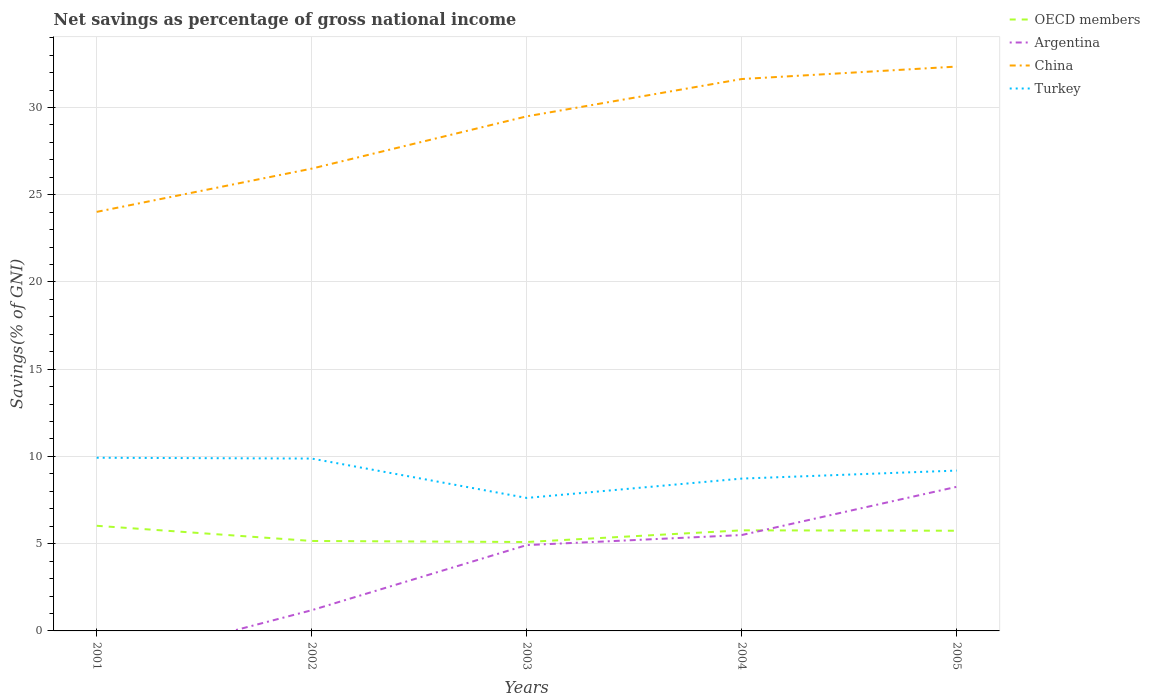How many different coloured lines are there?
Your response must be concise. 4. Does the line corresponding to China intersect with the line corresponding to Argentina?
Make the answer very short. No. Across all years, what is the maximum total savings in OECD members?
Provide a short and direct response. 5.1. What is the total total savings in OECD members in the graph?
Provide a succinct answer. -0.67. What is the difference between the highest and the second highest total savings in Argentina?
Ensure brevity in your answer.  8.26. What is the difference between the highest and the lowest total savings in China?
Offer a very short reply. 3. Does the graph contain grids?
Your response must be concise. Yes. Where does the legend appear in the graph?
Offer a terse response. Top right. How are the legend labels stacked?
Offer a terse response. Vertical. What is the title of the graph?
Provide a succinct answer. Net savings as percentage of gross national income. What is the label or title of the X-axis?
Your answer should be very brief. Years. What is the label or title of the Y-axis?
Your response must be concise. Savings(% of GNI). What is the Savings(% of GNI) of OECD members in 2001?
Provide a succinct answer. 6.03. What is the Savings(% of GNI) in Argentina in 2001?
Make the answer very short. 0. What is the Savings(% of GNI) in China in 2001?
Provide a short and direct response. 24.02. What is the Savings(% of GNI) in Turkey in 2001?
Make the answer very short. 9.93. What is the Savings(% of GNI) of OECD members in 2002?
Provide a short and direct response. 5.16. What is the Savings(% of GNI) of Argentina in 2002?
Your answer should be very brief. 1.19. What is the Savings(% of GNI) in China in 2002?
Your response must be concise. 26.49. What is the Savings(% of GNI) in Turkey in 2002?
Your answer should be compact. 9.88. What is the Savings(% of GNI) in OECD members in 2003?
Your response must be concise. 5.1. What is the Savings(% of GNI) of Argentina in 2003?
Give a very brief answer. 4.92. What is the Savings(% of GNI) of China in 2003?
Give a very brief answer. 29.49. What is the Savings(% of GNI) in Turkey in 2003?
Your answer should be compact. 7.62. What is the Savings(% of GNI) of OECD members in 2004?
Offer a very short reply. 5.76. What is the Savings(% of GNI) in Argentina in 2004?
Offer a terse response. 5.49. What is the Savings(% of GNI) of China in 2004?
Offer a terse response. 31.63. What is the Savings(% of GNI) of Turkey in 2004?
Ensure brevity in your answer.  8.73. What is the Savings(% of GNI) of OECD members in 2005?
Give a very brief answer. 5.74. What is the Savings(% of GNI) in Argentina in 2005?
Offer a terse response. 8.26. What is the Savings(% of GNI) of China in 2005?
Your answer should be compact. 32.34. What is the Savings(% of GNI) in Turkey in 2005?
Your response must be concise. 9.19. Across all years, what is the maximum Savings(% of GNI) in OECD members?
Ensure brevity in your answer.  6.03. Across all years, what is the maximum Savings(% of GNI) of Argentina?
Keep it short and to the point. 8.26. Across all years, what is the maximum Savings(% of GNI) of China?
Keep it short and to the point. 32.34. Across all years, what is the maximum Savings(% of GNI) in Turkey?
Your answer should be compact. 9.93. Across all years, what is the minimum Savings(% of GNI) in OECD members?
Give a very brief answer. 5.1. Across all years, what is the minimum Savings(% of GNI) of China?
Offer a terse response. 24.02. Across all years, what is the minimum Savings(% of GNI) of Turkey?
Keep it short and to the point. 7.62. What is the total Savings(% of GNI) of OECD members in the graph?
Provide a short and direct response. 27.78. What is the total Savings(% of GNI) of Argentina in the graph?
Provide a short and direct response. 19.86. What is the total Savings(% of GNI) of China in the graph?
Offer a very short reply. 143.98. What is the total Savings(% of GNI) of Turkey in the graph?
Your answer should be compact. 45.35. What is the difference between the Savings(% of GNI) of OECD members in 2001 and that in 2002?
Provide a short and direct response. 0.87. What is the difference between the Savings(% of GNI) in China in 2001 and that in 2002?
Your answer should be very brief. -2.48. What is the difference between the Savings(% of GNI) in Turkey in 2001 and that in 2002?
Give a very brief answer. 0.05. What is the difference between the Savings(% of GNI) in OECD members in 2001 and that in 2003?
Ensure brevity in your answer.  0.93. What is the difference between the Savings(% of GNI) in China in 2001 and that in 2003?
Provide a succinct answer. -5.47. What is the difference between the Savings(% of GNI) of Turkey in 2001 and that in 2003?
Offer a terse response. 2.3. What is the difference between the Savings(% of GNI) of OECD members in 2001 and that in 2004?
Provide a short and direct response. 0.26. What is the difference between the Savings(% of GNI) in China in 2001 and that in 2004?
Ensure brevity in your answer.  -7.61. What is the difference between the Savings(% of GNI) of Turkey in 2001 and that in 2004?
Your answer should be compact. 1.2. What is the difference between the Savings(% of GNI) of OECD members in 2001 and that in 2005?
Your answer should be compact. 0.28. What is the difference between the Savings(% of GNI) of China in 2001 and that in 2005?
Ensure brevity in your answer.  -8.33. What is the difference between the Savings(% of GNI) of Turkey in 2001 and that in 2005?
Offer a very short reply. 0.74. What is the difference between the Savings(% of GNI) in OECD members in 2002 and that in 2003?
Offer a terse response. 0.06. What is the difference between the Savings(% of GNI) of Argentina in 2002 and that in 2003?
Provide a succinct answer. -3.73. What is the difference between the Savings(% of GNI) in China in 2002 and that in 2003?
Give a very brief answer. -3. What is the difference between the Savings(% of GNI) of Turkey in 2002 and that in 2003?
Offer a very short reply. 2.26. What is the difference between the Savings(% of GNI) in OECD members in 2002 and that in 2004?
Your response must be concise. -0.61. What is the difference between the Savings(% of GNI) in Argentina in 2002 and that in 2004?
Provide a succinct answer. -4.31. What is the difference between the Savings(% of GNI) of China in 2002 and that in 2004?
Provide a succinct answer. -5.13. What is the difference between the Savings(% of GNI) in Turkey in 2002 and that in 2004?
Offer a very short reply. 1.15. What is the difference between the Savings(% of GNI) of OECD members in 2002 and that in 2005?
Give a very brief answer. -0.59. What is the difference between the Savings(% of GNI) in Argentina in 2002 and that in 2005?
Offer a terse response. -7.07. What is the difference between the Savings(% of GNI) in China in 2002 and that in 2005?
Ensure brevity in your answer.  -5.85. What is the difference between the Savings(% of GNI) in Turkey in 2002 and that in 2005?
Your answer should be compact. 0.69. What is the difference between the Savings(% of GNI) in OECD members in 2003 and that in 2004?
Your answer should be compact. -0.67. What is the difference between the Savings(% of GNI) of Argentina in 2003 and that in 2004?
Offer a very short reply. -0.58. What is the difference between the Savings(% of GNI) of China in 2003 and that in 2004?
Ensure brevity in your answer.  -2.14. What is the difference between the Savings(% of GNI) in Turkey in 2003 and that in 2004?
Provide a short and direct response. -1.11. What is the difference between the Savings(% of GNI) of OECD members in 2003 and that in 2005?
Your response must be concise. -0.65. What is the difference between the Savings(% of GNI) in Argentina in 2003 and that in 2005?
Give a very brief answer. -3.34. What is the difference between the Savings(% of GNI) of China in 2003 and that in 2005?
Make the answer very short. -2.85. What is the difference between the Savings(% of GNI) of Turkey in 2003 and that in 2005?
Offer a terse response. -1.57. What is the difference between the Savings(% of GNI) of OECD members in 2004 and that in 2005?
Offer a terse response. 0.02. What is the difference between the Savings(% of GNI) of Argentina in 2004 and that in 2005?
Keep it short and to the point. -2.76. What is the difference between the Savings(% of GNI) of China in 2004 and that in 2005?
Offer a very short reply. -0.71. What is the difference between the Savings(% of GNI) of Turkey in 2004 and that in 2005?
Your response must be concise. -0.46. What is the difference between the Savings(% of GNI) in OECD members in 2001 and the Savings(% of GNI) in Argentina in 2002?
Give a very brief answer. 4.84. What is the difference between the Savings(% of GNI) of OECD members in 2001 and the Savings(% of GNI) of China in 2002?
Give a very brief answer. -20.47. What is the difference between the Savings(% of GNI) of OECD members in 2001 and the Savings(% of GNI) of Turkey in 2002?
Provide a short and direct response. -3.85. What is the difference between the Savings(% of GNI) of China in 2001 and the Savings(% of GNI) of Turkey in 2002?
Make the answer very short. 14.14. What is the difference between the Savings(% of GNI) of OECD members in 2001 and the Savings(% of GNI) of Argentina in 2003?
Offer a terse response. 1.11. What is the difference between the Savings(% of GNI) in OECD members in 2001 and the Savings(% of GNI) in China in 2003?
Offer a terse response. -23.47. What is the difference between the Savings(% of GNI) of OECD members in 2001 and the Savings(% of GNI) of Turkey in 2003?
Offer a terse response. -1.6. What is the difference between the Savings(% of GNI) of China in 2001 and the Savings(% of GNI) of Turkey in 2003?
Your response must be concise. 16.4. What is the difference between the Savings(% of GNI) in OECD members in 2001 and the Savings(% of GNI) in Argentina in 2004?
Keep it short and to the point. 0.53. What is the difference between the Savings(% of GNI) in OECD members in 2001 and the Savings(% of GNI) in China in 2004?
Provide a short and direct response. -25.6. What is the difference between the Savings(% of GNI) in OECD members in 2001 and the Savings(% of GNI) in Turkey in 2004?
Offer a terse response. -2.7. What is the difference between the Savings(% of GNI) of China in 2001 and the Savings(% of GNI) of Turkey in 2004?
Keep it short and to the point. 15.29. What is the difference between the Savings(% of GNI) in OECD members in 2001 and the Savings(% of GNI) in Argentina in 2005?
Offer a terse response. -2.23. What is the difference between the Savings(% of GNI) of OECD members in 2001 and the Savings(% of GNI) of China in 2005?
Keep it short and to the point. -26.32. What is the difference between the Savings(% of GNI) in OECD members in 2001 and the Savings(% of GNI) in Turkey in 2005?
Offer a terse response. -3.16. What is the difference between the Savings(% of GNI) of China in 2001 and the Savings(% of GNI) of Turkey in 2005?
Provide a succinct answer. 14.83. What is the difference between the Savings(% of GNI) in OECD members in 2002 and the Savings(% of GNI) in Argentina in 2003?
Offer a terse response. 0.24. What is the difference between the Savings(% of GNI) in OECD members in 2002 and the Savings(% of GNI) in China in 2003?
Make the answer very short. -24.34. What is the difference between the Savings(% of GNI) in OECD members in 2002 and the Savings(% of GNI) in Turkey in 2003?
Offer a very short reply. -2.47. What is the difference between the Savings(% of GNI) of Argentina in 2002 and the Savings(% of GNI) of China in 2003?
Provide a short and direct response. -28.3. What is the difference between the Savings(% of GNI) in Argentina in 2002 and the Savings(% of GNI) in Turkey in 2003?
Keep it short and to the point. -6.43. What is the difference between the Savings(% of GNI) of China in 2002 and the Savings(% of GNI) of Turkey in 2003?
Make the answer very short. 18.87. What is the difference between the Savings(% of GNI) in OECD members in 2002 and the Savings(% of GNI) in Argentina in 2004?
Your answer should be very brief. -0.34. What is the difference between the Savings(% of GNI) of OECD members in 2002 and the Savings(% of GNI) of China in 2004?
Your answer should be compact. -26.47. What is the difference between the Savings(% of GNI) in OECD members in 2002 and the Savings(% of GNI) in Turkey in 2004?
Ensure brevity in your answer.  -3.58. What is the difference between the Savings(% of GNI) in Argentina in 2002 and the Savings(% of GNI) in China in 2004?
Your answer should be very brief. -30.44. What is the difference between the Savings(% of GNI) of Argentina in 2002 and the Savings(% of GNI) of Turkey in 2004?
Offer a very short reply. -7.54. What is the difference between the Savings(% of GNI) in China in 2002 and the Savings(% of GNI) in Turkey in 2004?
Offer a terse response. 17.76. What is the difference between the Savings(% of GNI) of OECD members in 2002 and the Savings(% of GNI) of Argentina in 2005?
Provide a succinct answer. -3.1. What is the difference between the Savings(% of GNI) of OECD members in 2002 and the Savings(% of GNI) of China in 2005?
Offer a terse response. -27.19. What is the difference between the Savings(% of GNI) of OECD members in 2002 and the Savings(% of GNI) of Turkey in 2005?
Offer a terse response. -4.03. What is the difference between the Savings(% of GNI) in Argentina in 2002 and the Savings(% of GNI) in China in 2005?
Your answer should be very brief. -31.16. What is the difference between the Savings(% of GNI) of Argentina in 2002 and the Savings(% of GNI) of Turkey in 2005?
Offer a very short reply. -8. What is the difference between the Savings(% of GNI) in China in 2002 and the Savings(% of GNI) in Turkey in 2005?
Provide a succinct answer. 17.3. What is the difference between the Savings(% of GNI) in OECD members in 2003 and the Savings(% of GNI) in Argentina in 2004?
Provide a succinct answer. -0.4. What is the difference between the Savings(% of GNI) of OECD members in 2003 and the Savings(% of GNI) of China in 2004?
Your response must be concise. -26.53. What is the difference between the Savings(% of GNI) of OECD members in 2003 and the Savings(% of GNI) of Turkey in 2004?
Keep it short and to the point. -3.63. What is the difference between the Savings(% of GNI) of Argentina in 2003 and the Savings(% of GNI) of China in 2004?
Offer a very short reply. -26.71. What is the difference between the Savings(% of GNI) in Argentina in 2003 and the Savings(% of GNI) in Turkey in 2004?
Give a very brief answer. -3.81. What is the difference between the Savings(% of GNI) of China in 2003 and the Savings(% of GNI) of Turkey in 2004?
Provide a short and direct response. 20.76. What is the difference between the Savings(% of GNI) of OECD members in 2003 and the Savings(% of GNI) of Argentina in 2005?
Make the answer very short. -3.16. What is the difference between the Savings(% of GNI) in OECD members in 2003 and the Savings(% of GNI) in China in 2005?
Keep it short and to the point. -27.25. What is the difference between the Savings(% of GNI) of OECD members in 2003 and the Savings(% of GNI) of Turkey in 2005?
Your answer should be very brief. -4.09. What is the difference between the Savings(% of GNI) of Argentina in 2003 and the Savings(% of GNI) of China in 2005?
Your answer should be very brief. -27.43. What is the difference between the Savings(% of GNI) of Argentina in 2003 and the Savings(% of GNI) of Turkey in 2005?
Provide a short and direct response. -4.27. What is the difference between the Savings(% of GNI) in China in 2003 and the Savings(% of GNI) in Turkey in 2005?
Your answer should be compact. 20.3. What is the difference between the Savings(% of GNI) of OECD members in 2004 and the Savings(% of GNI) of Argentina in 2005?
Give a very brief answer. -2.49. What is the difference between the Savings(% of GNI) in OECD members in 2004 and the Savings(% of GNI) in China in 2005?
Provide a short and direct response. -26.58. What is the difference between the Savings(% of GNI) of OECD members in 2004 and the Savings(% of GNI) of Turkey in 2005?
Provide a succinct answer. -3.43. What is the difference between the Savings(% of GNI) in Argentina in 2004 and the Savings(% of GNI) in China in 2005?
Your response must be concise. -26.85. What is the difference between the Savings(% of GNI) of Argentina in 2004 and the Savings(% of GNI) of Turkey in 2005?
Provide a succinct answer. -3.69. What is the difference between the Savings(% of GNI) of China in 2004 and the Savings(% of GNI) of Turkey in 2005?
Give a very brief answer. 22.44. What is the average Savings(% of GNI) of OECD members per year?
Your answer should be compact. 5.56. What is the average Savings(% of GNI) of Argentina per year?
Make the answer very short. 3.97. What is the average Savings(% of GNI) of China per year?
Make the answer very short. 28.8. What is the average Savings(% of GNI) in Turkey per year?
Your answer should be very brief. 9.07. In the year 2001, what is the difference between the Savings(% of GNI) in OECD members and Savings(% of GNI) in China?
Your answer should be very brief. -17.99. In the year 2001, what is the difference between the Savings(% of GNI) of OECD members and Savings(% of GNI) of Turkey?
Your answer should be very brief. -3.9. In the year 2001, what is the difference between the Savings(% of GNI) in China and Savings(% of GNI) in Turkey?
Ensure brevity in your answer.  14.09. In the year 2002, what is the difference between the Savings(% of GNI) in OECD members and Savings(% of GNI) in Argentina?
Provide a succinct answer. 3.97. In the year 2002, what is the difference between the Savings(% of GNI) of OECD members and Savings(% of GNI) of China?
Keep it short and to the point. -21.34. In the year 2002, what is the difference between the Savings(% of GNI) in OECD members and Savings(% of GNI) in Turkey?
Your answer should be very brief. -4.72. In the year 2002, what is the difference between the Savings(% of GNI) in Argentina and Savings(% of GNI) in China?
Offer a terse response. -25.31. In the year 2002, what is the difference between the Savings(% of GNI) of Argentina and Savings(% of GNI) of Turkey?
Give a very brief answer. -8.69. In the year 2002, what is the difference between the Savings(% of GNI) in China and Savings(% of GNI) in Turkey?
Make the answer very short. 16.62. In the year 2003, what is the difference between the Savings(% of GNI) in OECD members and Savings(% of GNI) in Argentina?
Provide a short and direct response. 0.18. In the year 2003, what is the difference between the Savings(% of GNI) in OECD members and Savings(% of GNI) in China?
Your answer should be compact. -24.39. In the year 2003, what is the difference between the Savings(% of GNI) of OECD members and Savings(% of GNI) of Turkey?
Your response must be concise. -2.53. In the year 2003, what is the difference between the Savings(% of GNI) in Argentina and Savings(% of GNI) in China?
Your response must be concise. -24.57. In the year 2003, what is the difference between the Savings(% of GNI) of Argentina and Savings(% of GNI) of Turkey?
Keep it short and to the point. -2.7. In the year 2003, what is the difference between the Savings(% of GNI) of China and Savings(% of GNI) of Turkey?
Offer a terse response. 21.87. In the year 2004, what is the difference between the Savings(% of GNI) of OECD members and Savings(% of GNI) of Argentina?
Your answer should be very brief. 0.27. In the year 2004, what is the difference between the Savings(% of GNI) of OECD members and Savings(% of GNI) of China?
Provide a succinct answer. -25.87. In the year 2004, what is the difference between the Savings(% of GNI) of OECD members and Savings(% of GNI) of Turkey?
Your answer should be compact. -2.97. In the year 2004, what is the difference between the Savings(% of GNI) of Argentina and Savings(% of GNI) of China?
Your answer should be compact. -26.13. In the year 2004, what is the difference between the Savings(% of GNI) in Argentina and Savings(% of GNI) in Turkey?
Provide a succinct answer. -3.24. In the year 2004, what is the difference between the Savings(% of GNI) in China and Savings(% of GNI) in Turkey?
Offer a very short reply. 22.9. In the year 2005, what is the difference between the Savings(% of GNI) of OECD members and Savings(% of GNI) of Argentina?
Your answer should be compact. -2.52. In the year 2005, what is the difference between the Savings(% of GNI) of OECD members and Savings(% of GNI) of China?
Your answer should be very brief. -26.6. In the year 2005, what is the difference between the Savings(% of GNI) in OECD members and Savings(% of GNI) in Turkey?
Your response must be concise. -3.45. In the year 2005, what is the difference between the Savings(% of GNI) in Argentina and Savings(% of GNI) in China?
Your response must be concise. -24.09. In the year 2005, what is the difference between the Savings(% of GNI) in Argentina and Savings(% of GNI) in Turkey?
Give a very brief answer. -0.93. In the year 2005, what is the difference between the Savings(% of GNI) in China and Savings(% of GNI) in Turkey?
Give a very brief answer. 23.15. What is the ratio of the Savings(% of GNI) in OECD members in 2001 to that in 2002?
Your answer should be compact. 1.17. What is the ratio of the Savings(% of GNI) of China in 2001 to that in 2002?
Make the answer very short. 0.91. What is the ratio of the Savings(% of GNI) of Turkey in 2001 to that in 2002?
Provide a short and direct response. 1. What is the ratio of the Savings(% of GNI) in OECD members in 2001 to that in 2003?
Provide a short and direct response. 1.18. What is the ratio of the Savings(% of GNI) of China in 2001 to that in 2003?
Provide a succinct answer. 0.81. What is the ratio of the Savings(% of GNI) in Turkey in 2001 to that in 2003?
Offer a terse response. 1.3. What is the ratio of the Savings(% of GNI) in OECD members in 2001 to that in 2004?
Offer a terse response. 1.05. What is the ratio of the Savings(% of GNI) in China in 2001 to that in 2004?
Offer a very short reply. 0.76. What is the ratio of the Savings(% of GNI) of Turkey in 2001 to that in 2004?
Provide a succinct answer. 1.14. What is the ratio of the Savings(% of GNI) of OECD members in 2001 to that in 2005?
Your answer should be very brief. 1.05. What is the ratio of the Savings(% of GNI) in China in 2001 to that in 2005?
Keep it short and to the point. 0.74. What is the ratio of the Savings(% of GNI) of OECD members in 2002 to that in 2003?
Keep it short and to the point. 1.01. What is the ratio of the Savings(% of GNI) of Argentina in 2002 to that in 2003?
Offer a terse response. 0.24. What is the ratio of the Savings(% of GNI) in China in 2002 to that in 2003?
Your answer should be very brief. 0.9. What is the ratio of the Savings(% of GNI) in Turkey in 2002 to that in 2003?
Keep it short and to the point. 1.3. What is the ratio of the Savings(% of GNI) of OECD members in 2002 to that in 2004?
Ensure brevity in your answer.  0.89. What is the ratio of the Savings(% of GNI) in Argentina in 2002 to that in 2004?
Your response must be concise. 0.22. What is the ratio of the Savings(% of GNI) of China in 2002 to that in 2004?
Keep it short and to the point. 0.84. What is the ratio of the Savings(% of GNI) in Turkey in 2002 to that in 2004?
Offer a very short reply. 1.13. What is the ratio of the Savings(% of GNI) of OECD members in 2002 to that in 2005?
Your answer should be compact. 0.9. What is the ratio of the Savings(% of GNI) in Argentina in 2002 to that in 2005?
Make the answer very short. 0.14. What is the ratio of the Savings(% of GNI) in China in 2002 to that in 2005?
Provide a succinct answer. 0.82. What is the ratio of the Savings(% of GNI) in Turkey in 2002 to that in 2005?
Make the answer very short. 1.07. What is the ratio of the Savings(% of GNI) in OECD members in 2003 to that in 2004?
Your response must be concise. 0.88. What is the ratio of the Savings(% of GNI) in Argentina in 2003 to that in 2004?
Provide a succinct answer. 0.9. What is the ratio of the Savings(% of GNI) in China in 2003 to that in 2004?
Your answer should be compact. 0.93. What is the ratio of the Savings(% of GNI) of Turkey in 2003 to that in 2004?
Provide a succinct answer. 0.87. What is the ratio of the Savings(% of GNI) of OECD members in 2003 to that in 2005?
Provide a short and direct response. 0.89. What is the ratio of the Savings(% of GNI) in Argentina in 2003 to that in 2005?
Ensure brevity in your answer.  0.6. What is the ratio of the Savings(% of GNI) of China in 2003 to that in 2005?
Provide a short and direct response. 0.91. What is the ratio of the Savings(% of GNI) of Turkey in 2003 to that in 2005?
Provide a succinct answer. 0.83. What is the ratio of the Savings(% of GNI) of Argentina in 2004 to that in 2005?
Your answer should be very brief. 0.67. What is the ratio of the Savings(% of GNI) of China in 2004 to that in 2005?
Your answer should be compact. 0.98. What is the difference between the highest and the second highest Savings(% of GNI) of OECD members?
Ensure brevity in your answer.  0.26. What is the difference between the highest and the second highest Savings(% of GNI) of Argentina?
Your answer should be compact. 2.76. What is the difference between the highest and the second highest Savings(% of GNI) in China?
Offer a terse response. 0.71. What is the difference between the highest and the second highest Savings(% of GNI) in Turkey?
Give a very brief answer. 0.05. What is the difference between the highest and the lowest Savings(% of GNI) of OECD members?
Ensure brevity in your answer.  0.93. What is the difference between the highest and the lowest Savings(% of GNI) in Argentina?
Your response must be concise. 8.26. What is the difference between the highest and the lowest Savings(% of GNI) of China?
Your response must be concise. 8.33. What is the difference between the highest and the lowest Savings(% of GNI) in Turkey?
Give a very brief answer. 2.3. 